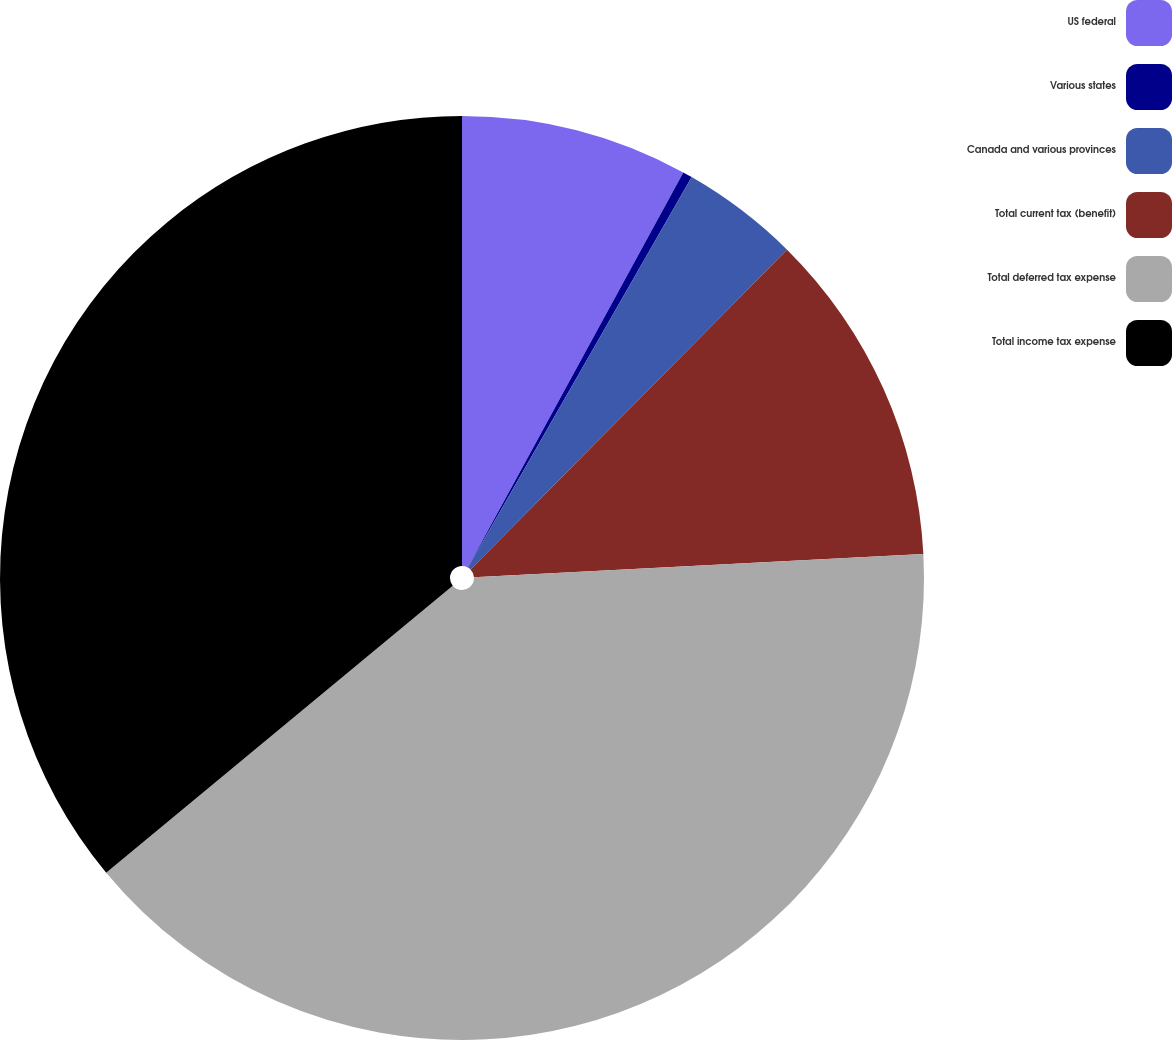<chart> <loc_0><loc_0><loc_500><loc_500><pie_chart><fcel>US federal<fcel>Various states<fcel>Canada and various provinces<fcel>Total current tax (benefit)<fcel>Total deferred tax expense<fcel>Total income tax expense<nl><fcel>7.95%<fcel>0.33%<fcel>4.14%<fcel>11.75%<fcel>39.82%<fcel>36.01%<nl></chart> 